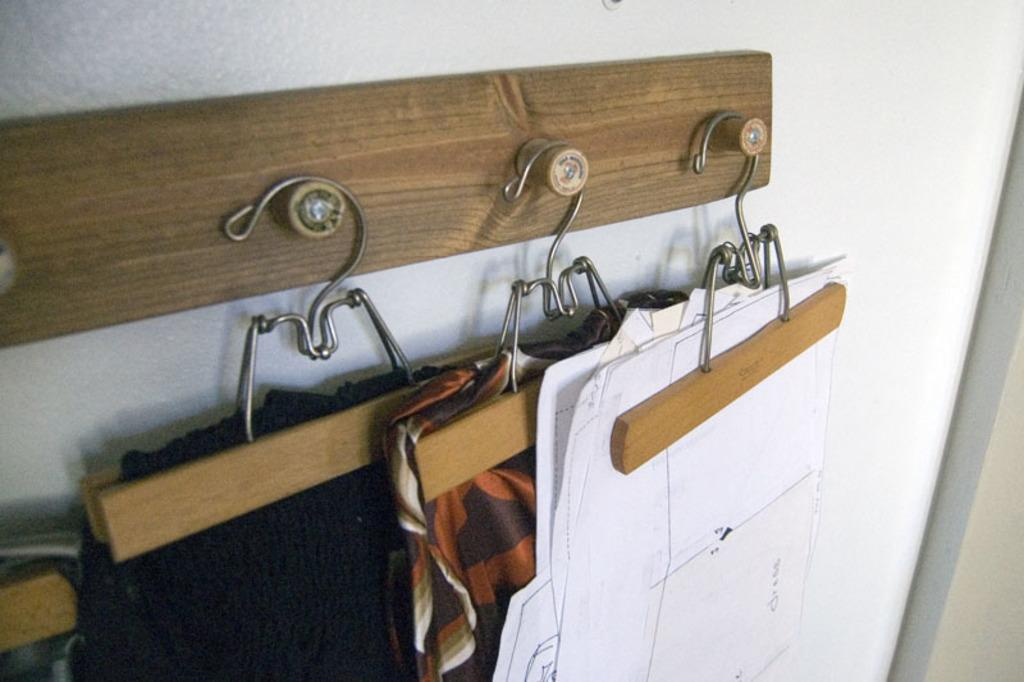What is hanging on the wooden board in the image? There are clothes and papers on hangers in the image. What material is the board made of? The hangers are placed on a wooden board. What type of canvas is being used to plough the field in the image? There is no canvas or plough present in the image; it features clothes and papers on hangers placed on a wooden board. 